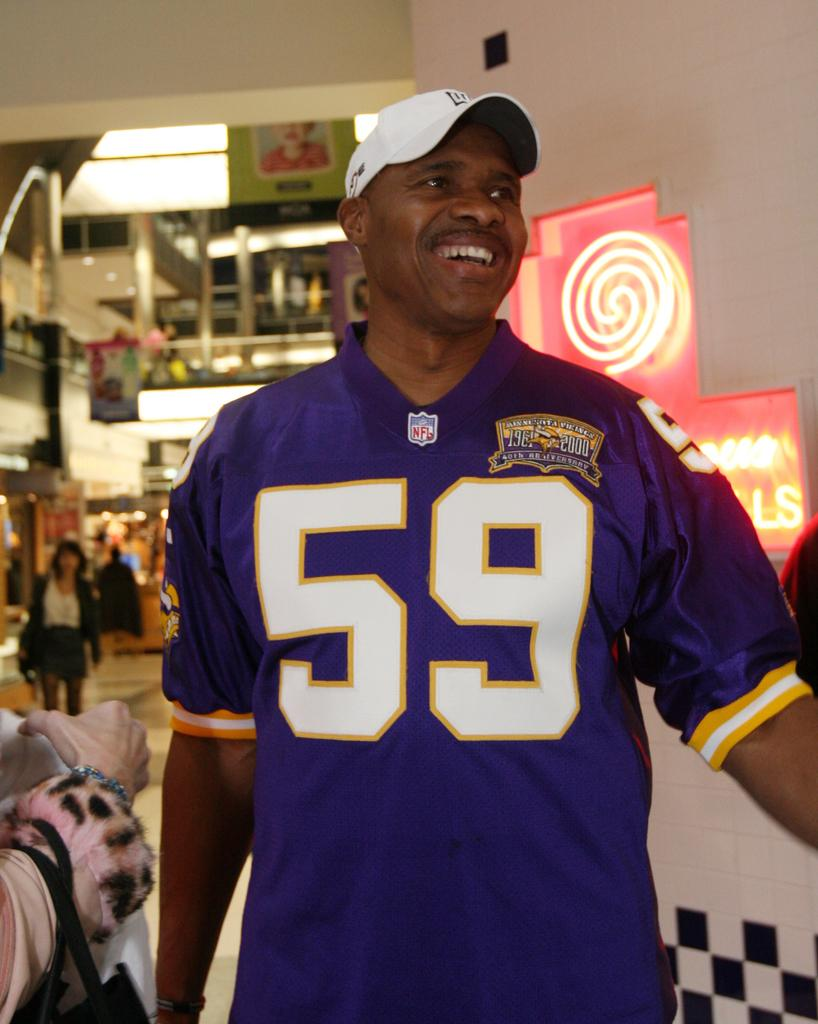<image>
Render a clear and concise summary of the photo. A man in a number 59 jersey smiles at someone. 